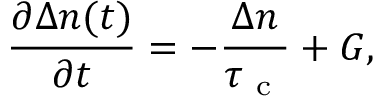<formula> <loc_0><loc_0><loc_500><loc_500>\frac { \partial \Delta n ( t ) } { \partial t } = - \frac { \Delta n } { \tau _ { c } } + G ,</formula> 